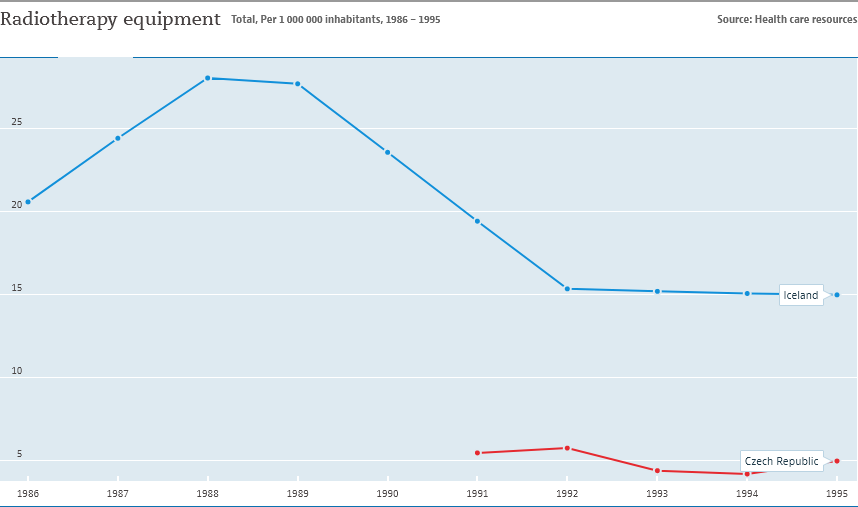What impact might the changes in radiotherapy equipment have on patient care? Changes in the availability of radiotherapy equipment could have significant impacts on patient care. An increase in equipment may reduce waiting times and improve access to treatment. Conversely, a decline might lead to longer waiting periods, potential delays in treatment, and could be indicative of resource reallocation or changes in healthcare policy. 